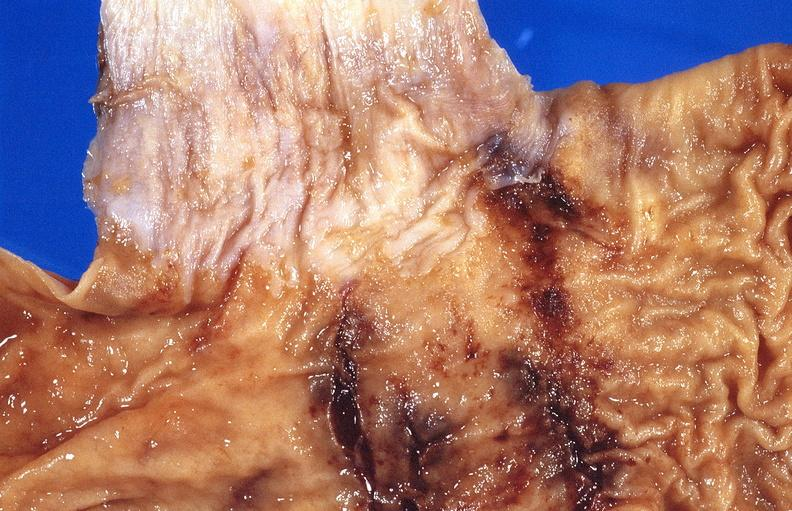what does this image show?
Answer the question using a single word or phrase. Stomach 